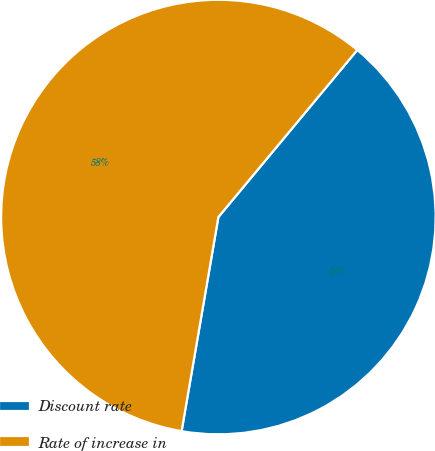Convert chart. <chart><loc_0><loc_0><loc_500><loc_500><pie_chart><fcel>Discount rate<fcel>Rate of increase in<nl><fcel>41.67%<fcel>58.33%<nl></chart> 